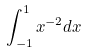Convert formula to latex. <formula><loc_0><loc_0><loc_500><loc_500>\int _ { - 1 } ^ { 1 } x ^ { - 2 } d x</formula> 